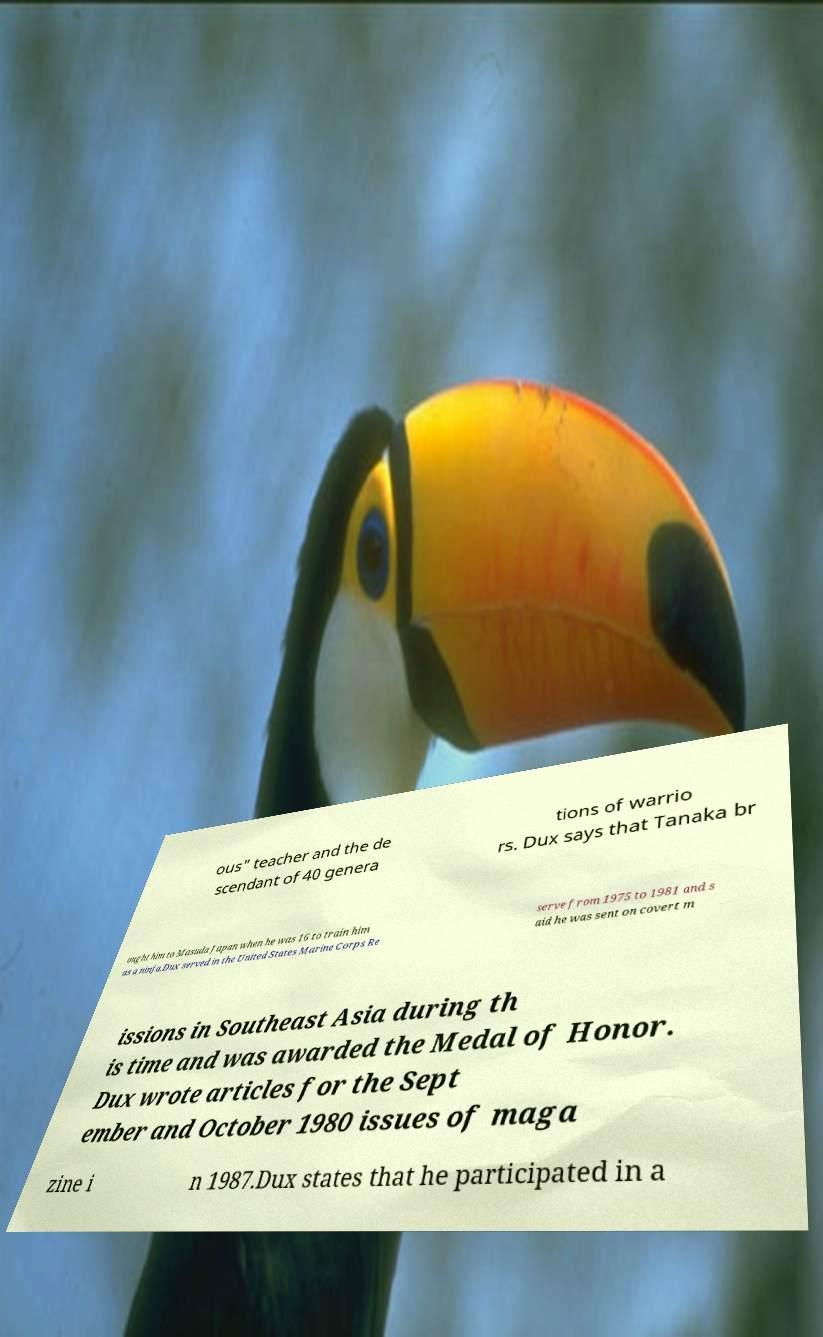Could you extract and type out the text from this image? ous" teacher and the de scendant of 40 genera tions of warrio rs. Dux says that Tanaka br ought him to Masuda Japan when he was 16 to train him as a ninja.Dux served in the United States Marine Corps Re serve from 1975 to 1981 and s aid he was sent on covert m issions in Southeast Asia during th is time and was awarded the Medal of Honor. Dux wrote articles for the Sept ember and October 1980 issues of maga zine i n 1987.Dux states that he participated in a 